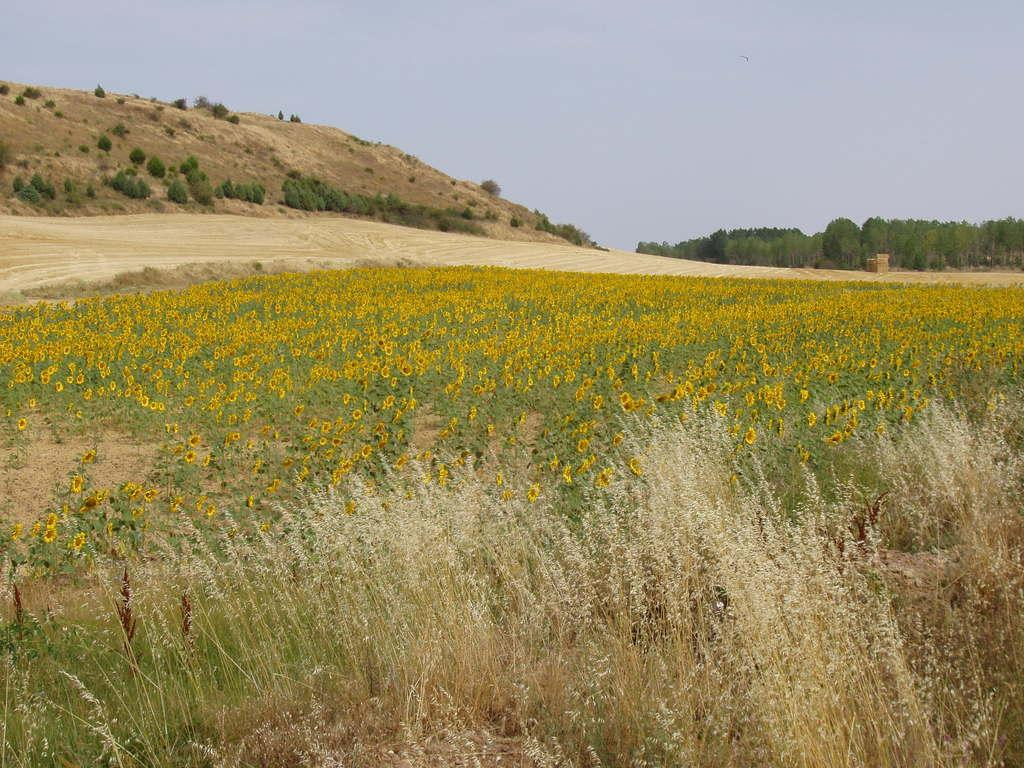What is the main subject of the image? The main subject of the image is a sunflower field. What can be seen in the background of the image? In the background of the image, there is a mountain and trees. What part of the natural environment is visible in the image? The sky is visible in the background of the image. Can you see any railway tracks in the image? There are no railway tracks visible in the image. Are there any ants crawling on the sunflower petals in the image? There is no indication of ants or any other insects in the image. 